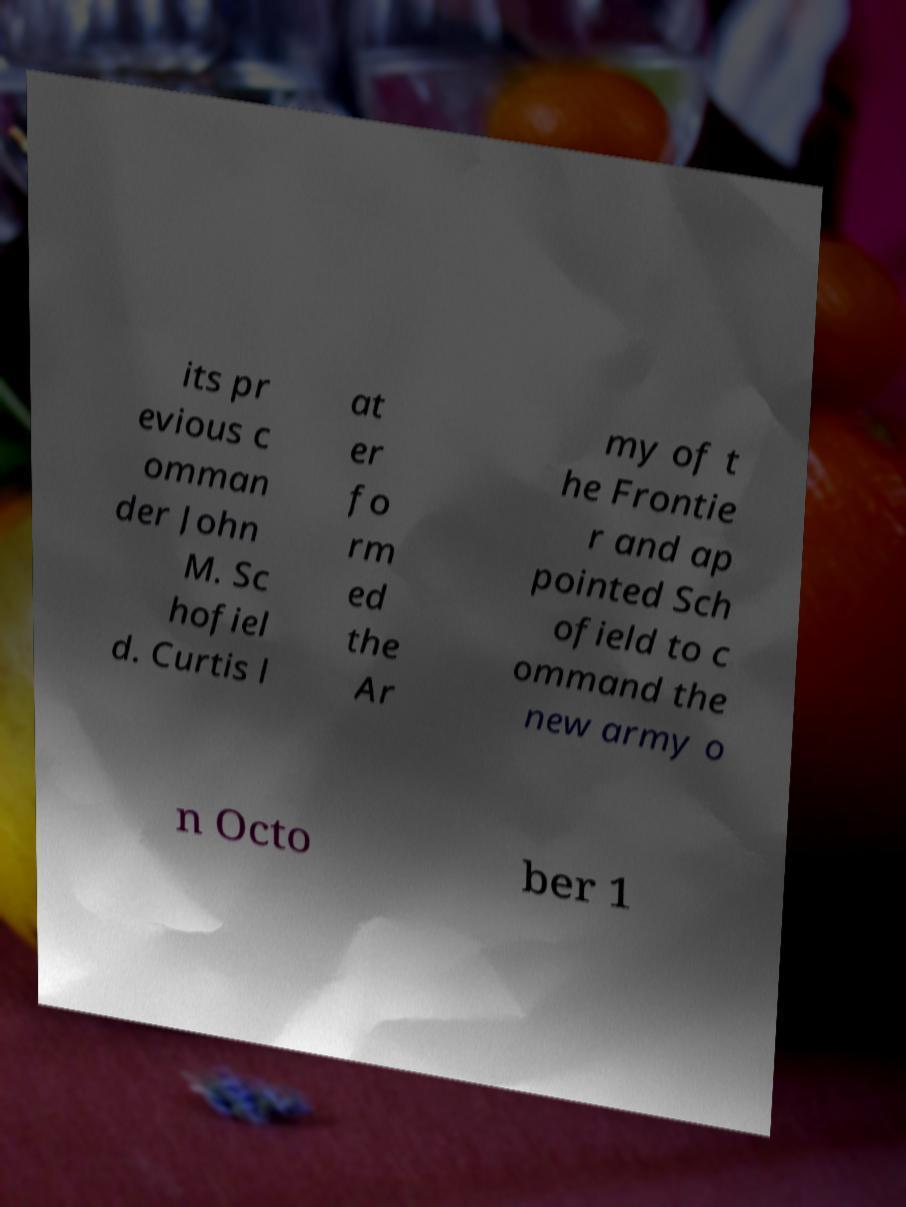Can you describe the item in the image with the text on it? Certainly! The photo shows a piece of paper with a blurry text printed on it. The text seems to be about a historical figure and a specific date, but the blurry quality and fold in the paper obscure parts of the content, making it difficult to transcribe completely. 